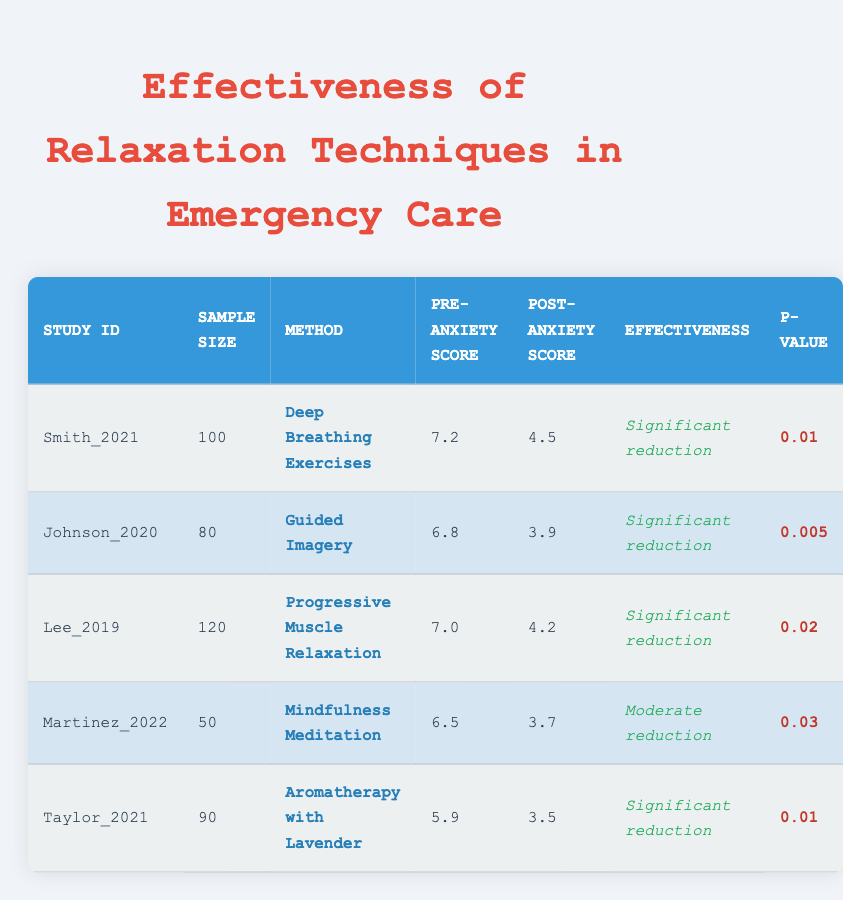What was the pre-anxiety score for the study by Johnson in 2020? The table indicates that Johnson's study in 2020 had a pre-anxiety score of 6.8, which can be found under the "Pre-Anxiety Score" column for that study.
Answer: 6.8 Which relaxation technique had the highest post-anxiety score? In the table, the post-anxiety scores are 4.5 for Deep Breathing, 3.9 for Guided Imagery, 4.2 for Progressive Muscle Relaxation, 3.7 for Mindfulness Meditation, and 3.5 for Aromatherapy with Lavender. The highest post-anxiety score is 4.5 from the Deep Breathing technique.
Answer: 4.5 Is the effectiveness of Aromatherapy with Lavender significant? The effectiveness of Aromatherapy with Lavender is listed as a significant reduction based on the effectiveness column, confirming it as significant.
Answer: Yes What is the average pre-anxiety score for the relaxation techniques studied? The average pre-anxiety score can be calculated by summing the pre-anxiety scores (7.2 + 6.8 + 7.0 + 6.5 + 5.9 = 33.4) and dividing by the number of studies (5). Thus, the average is 33.4 / 5 = 6.68.
Answer: 6.68 How many studies reported a moderate reduction in anxiety? From the table, only one study, Martinez in 2022 with Mindfulness Meditation, reported moderate reduction, while the others indicated significant reduction.
Answer: 1 Which technique had the lowest p-value, and what does that imply about its effectiveness? The technique with the lowest p-value is Guided Imagery (0.005). A p-value less than 0.01 typically implies strong evidence against the null hypothesis, suggesting it is very effective in reducing anxiety.
Answer: Guided Imagery; indicates strong effectiveness What is the total sample size across all studies? The total sample size can be derived from adding each individual sample size: 100 from Smith, 80 from Johnson, 120 from Lee, 50 from Martinez, and 90 from Taylor, which totals (100 + 80 + 120 + 50 + 90 = 440).
Answer: 440 Did all studies show significant reductions in anxiety? No, the study by Martinez in 2022 showed a moderate reduction, while the others indicated a significant reduction.
Answer: No What was the range of pre-anxiety scores across these studies? The pre-anxiety scores range from 5.9 (Aromatherapy with Lavender) to 7.2 (Deep Breathing Exercises). Thus, the range can be calculated as 7.2 - 5.9 = 1.3.
Answer: 1.3 